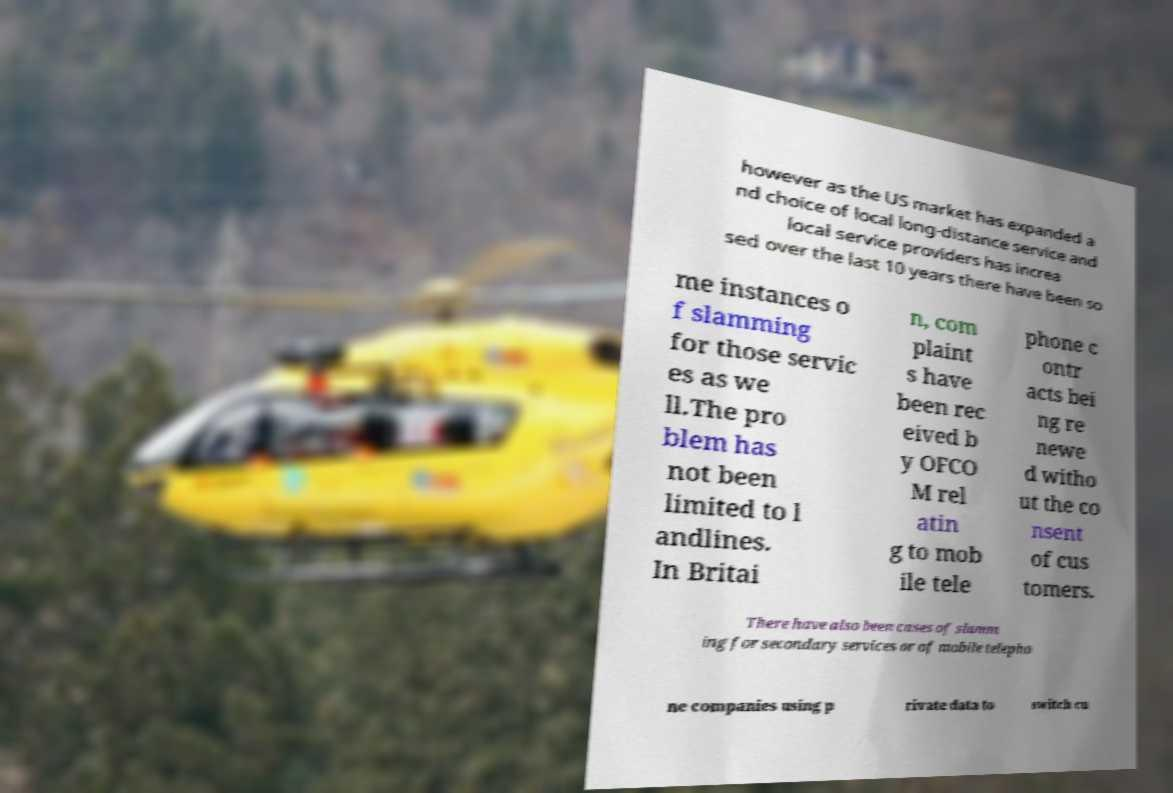What messages or text are displayed in this image? I need them in a readable, typed format. however as the US market has expanded a nd choice of local long-distance service and local service providers has increa sed over the last 10 years there have been so me instances o f slamming for those servic es as we ll.The pro blem has not been limited to l andlines. In Britai n, com plaint s have been rec eived b y OFCO M rel atin g to mob ile tele phone c ontr acts bei ng re newe d witho ut the co nsent of cus tomers. There have also been cases of slamm ing for secondary services or of mobile telepho ne companies using p rivate data to switch cu 